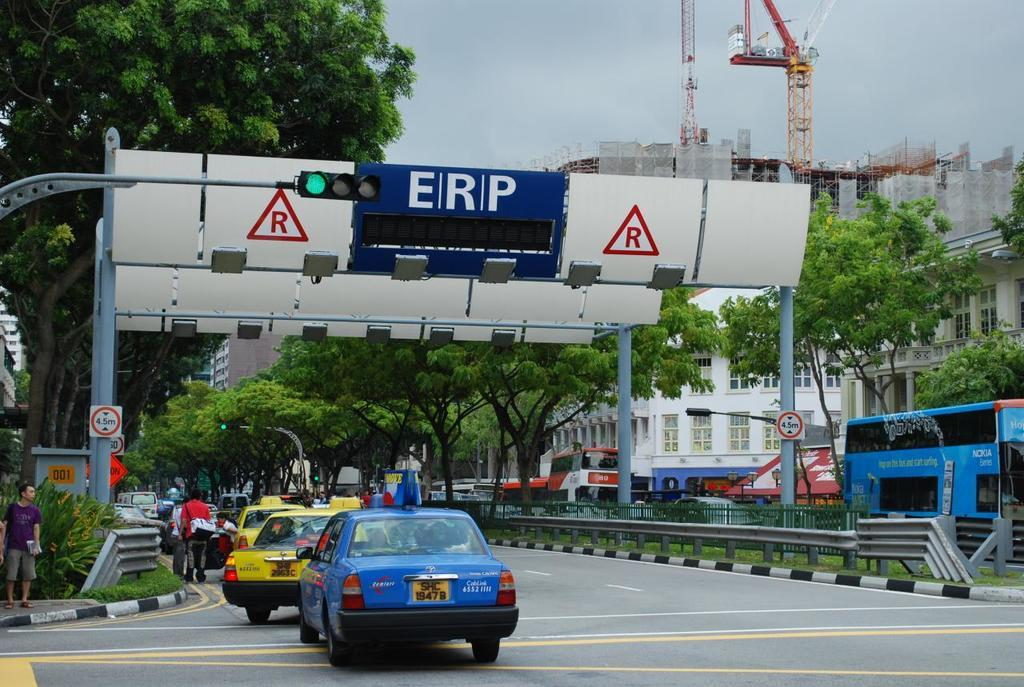<image>
Summarize the visual content of the image. A road with a blue car in front has a sign above it with ERP. 